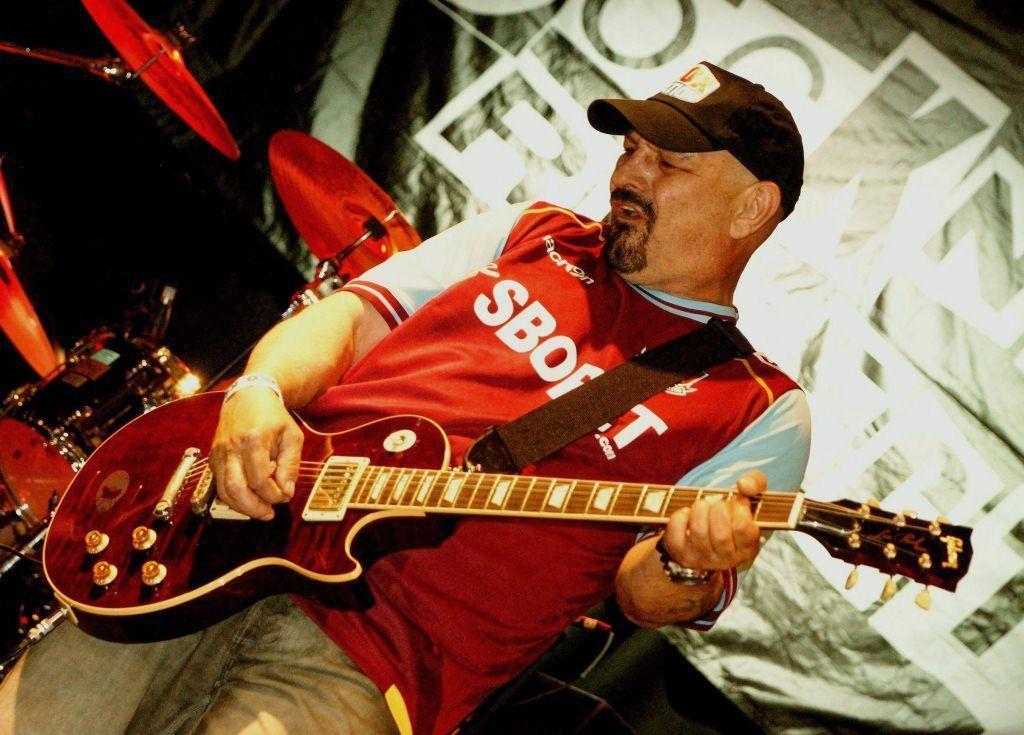Can you describe this image briefly? In this image we can see a person standing and playing a guitar and also we can see some musical instruments, in the background, we can see a banner. 